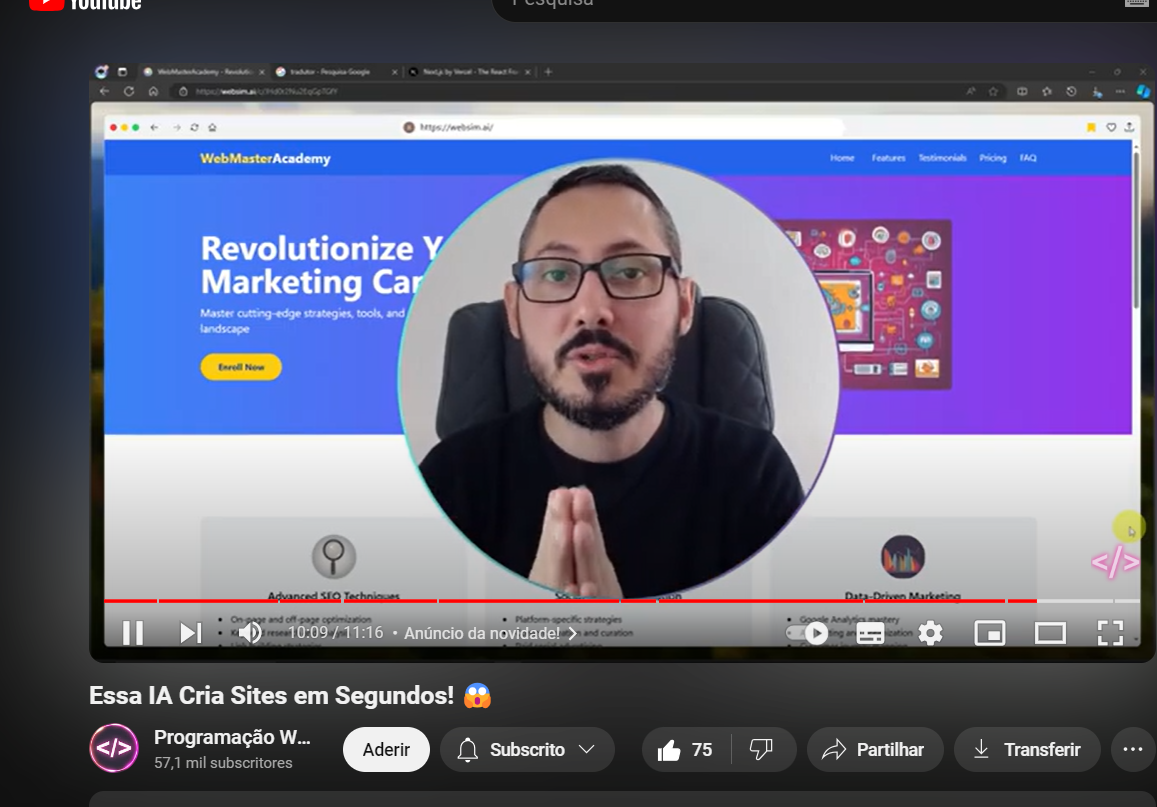o que e isso?
 A imagem mostra uma pessoa com cabelo escuro, usando uma faixa na cabeça e brincos. A pessoa está com batom vermelho e parece estar posando para a foto em um ambiente com um fundo floral. 

Se precisar de mais informações ou tiver outra pergunta, estou à disposição! descrver de forma informal Na imagem, temos um print de um vídeo do YouTube. O vídeo está sendo apresentado por uma pessoa de óculos e barba, que está falando sobre uma IA que cria sites em segundos. O título do vídeo diz: "Essa IA Cria Sites em Segundos! 😱". No fundo, dá pra ver uma tela com um site chamado "WebMasterAcademy" que está falando sobre marketing digital. O canal que postou o vídeo se chama "Programação Web" e tem 57,1 mil inscritos. A pessoa do vídeo parece estar se explicando ou ensinando algo, com as mãos juntas, tipo em oração. 